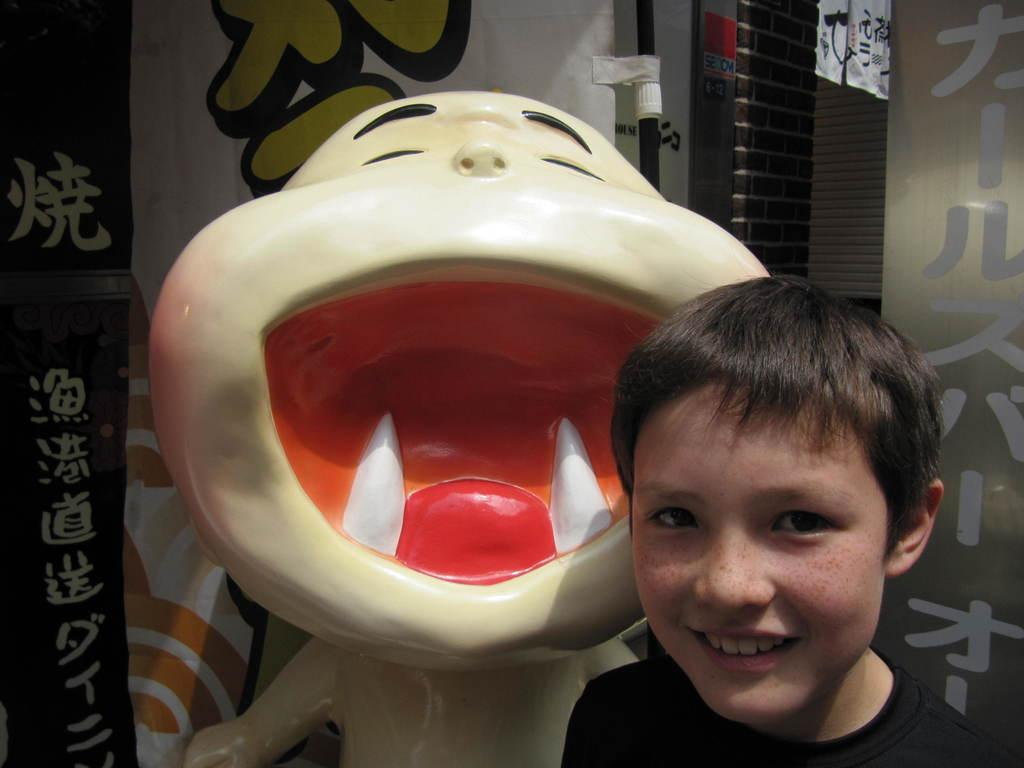Who or what is the main subject in the image? There is a boy in the image. What is located behind the boy in the image? There is a statue behind the boy in the image. What type of architectural feature is present in the image? There is a wall in the image. What type of bread can be seen in the image? There is no bread present in the image. How does the moon compare in size to the statue in the image? The image does not contain the moon, so it is not possible to make a comparison between the moon and the statue. 